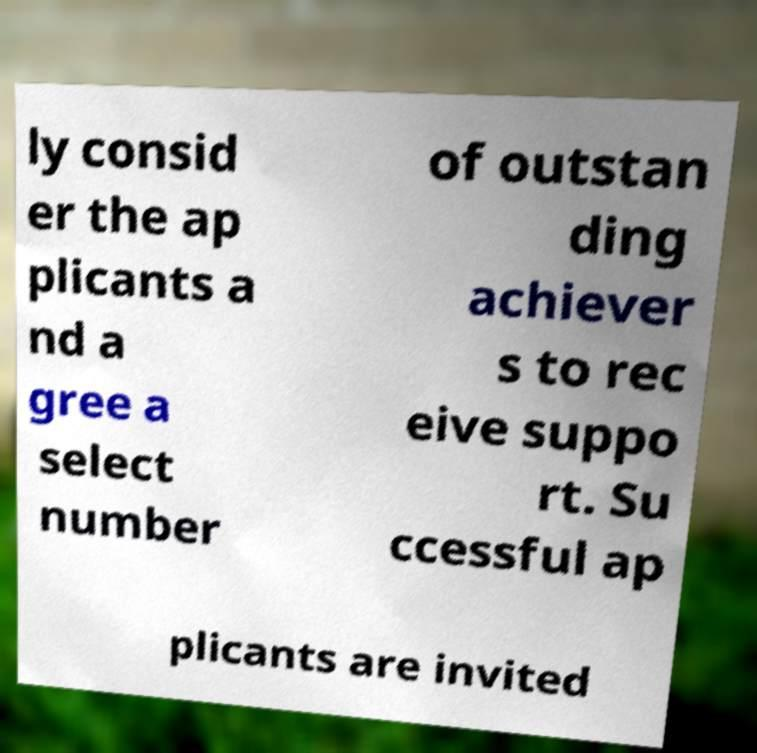Could you assist in decoding the text presented in this image and type it out clearly? ly consid er the ap plicants a nd a gree a select number of outstan ding achiever s to rec eive suppo rt. Su ccessful ap plicants are invited 